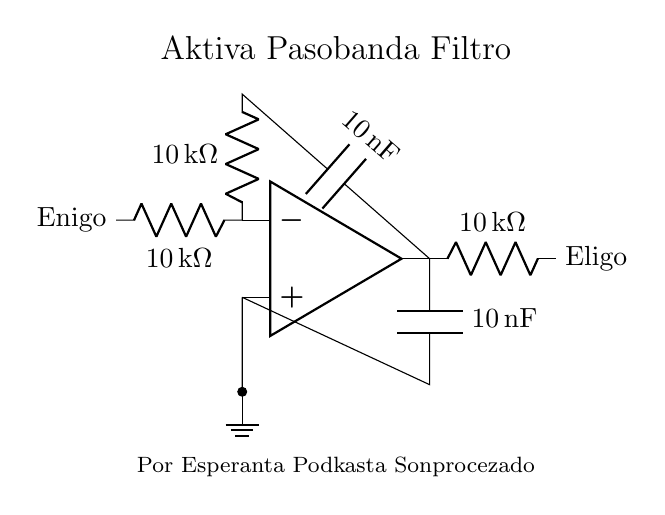What components are present in the circuit? The circuit contains an operational amplifier, resistors, and capacitors. There is a resistor with a value of 10 kiloohms, a capacitor with a value of 10 nanofarads, and a ground connection.
Answer: operational amplifier, resistors, capacitors What is the value of the input resistor? The input resistor value can be found by examining the label on the resistor connected to the inverting input of the operational amplifier. It is labeled as 10 kiloohms.
Answer: 10 kiloohms What type of filter is represented in this circuit? The label in the circuit diagram explicitly states that this is an active bandpass filter. The design is intended to allow certain frequencies to pass while attenuating others.
Answer: active bandpass filter How many capacitors are used in the circuit? By visually inspecting the circuit diagram, we can see there is one capacitor connected to the output of the operational amplifier.
Answer: one What is the output connection labeled as? The output from the operational amplifier in the circuit is labeled as "Eligo," indicating where the filtered signal will be accessed.
Answer: Eligo What is the purpose of the capacitor in the circuit? The capacitor in the circuit plays a crucial role in determining the frequency response of the filter. Specifically, it blocks direct current and allows alternating current to pass, shaping the filter characteristics.
Answer: frequency response shaping How does the resistor value affect the filter performance? The value of the resistors in the circuit directly influences the cutoff frequencies of the bandpass filter. A higher resistance would shift the frequency response, potentially allowing less of certain frequencies to pass, whereas a lower resistance would have the opposite effect.
Answer: shifts cutoff frequencies 